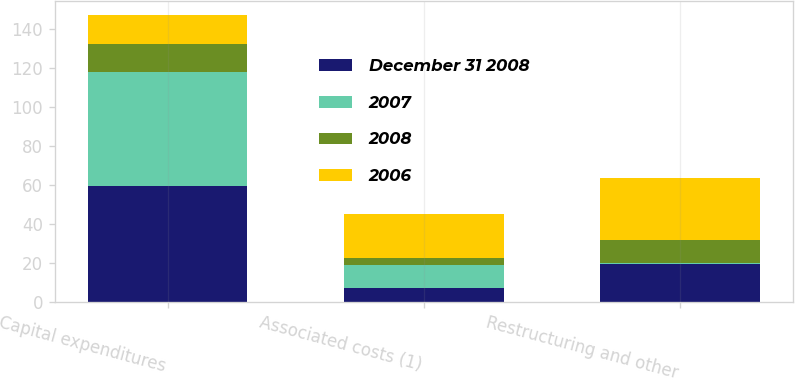<chart> <loc_0><loc_0><loc_500><loc_500><stacked_bar_chart><ecel><fcel>Capital expenditures<fcel>Associated costs (1)<fcel>Restructuring and other<nl><fcel>December 31 2008<fcel>59.5<fcel>7.4<fcel>19.3<nl><fcel>2007<fcel>58.5<fcel>11.4<fcel>0.7<nl><fcel>2008<fcel>14.7<fcel>3.8<fcel>11.8<nl><fcel>2006<fcel>14.7<fcel>22.6<fcel>31.8<nl></chart> 